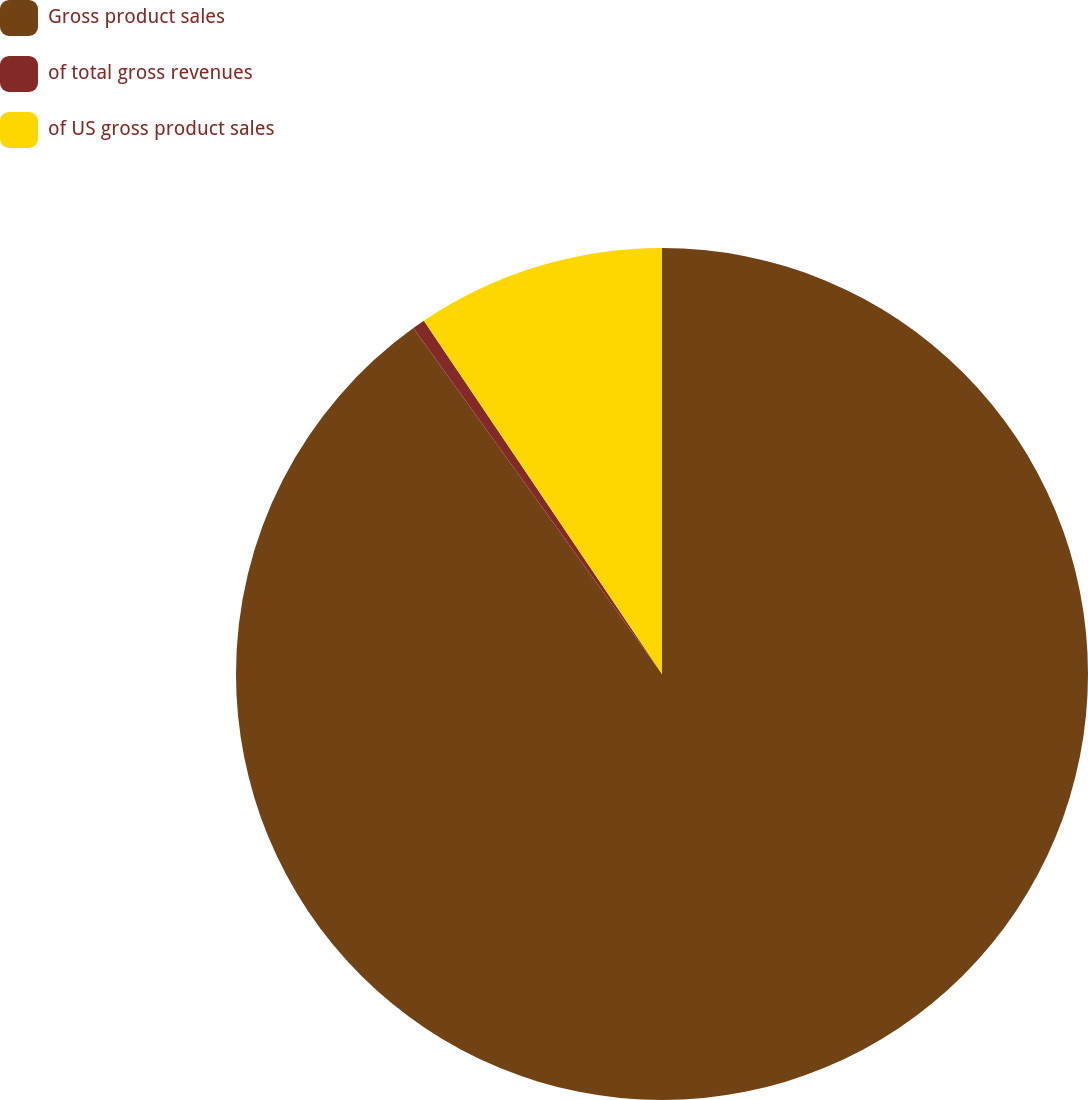Convert chart. <chart><loc_0><loc_0><loc_500><loc_500><pie_chart><fcel>Gross product sales<fcel>of total gross revenues<fcel>of US gross product sales<nl><fcel>90.07%<fcel>0.48%<fcel>9.44%<nl></chart> 